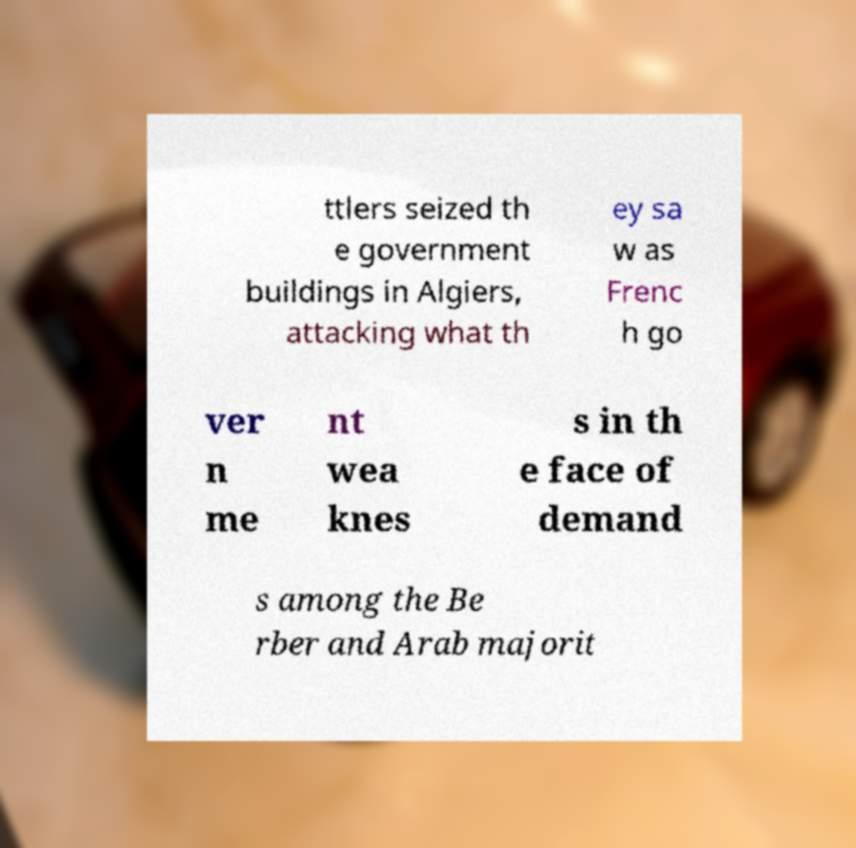Please identify and transcribe the text found in this image. ttlers seized th e government buildings in Algiers, attacking what th ey sa w as Frenc h go ver n me nt wea knes s in th e face of demand s among the Be rber and Arab majorit 